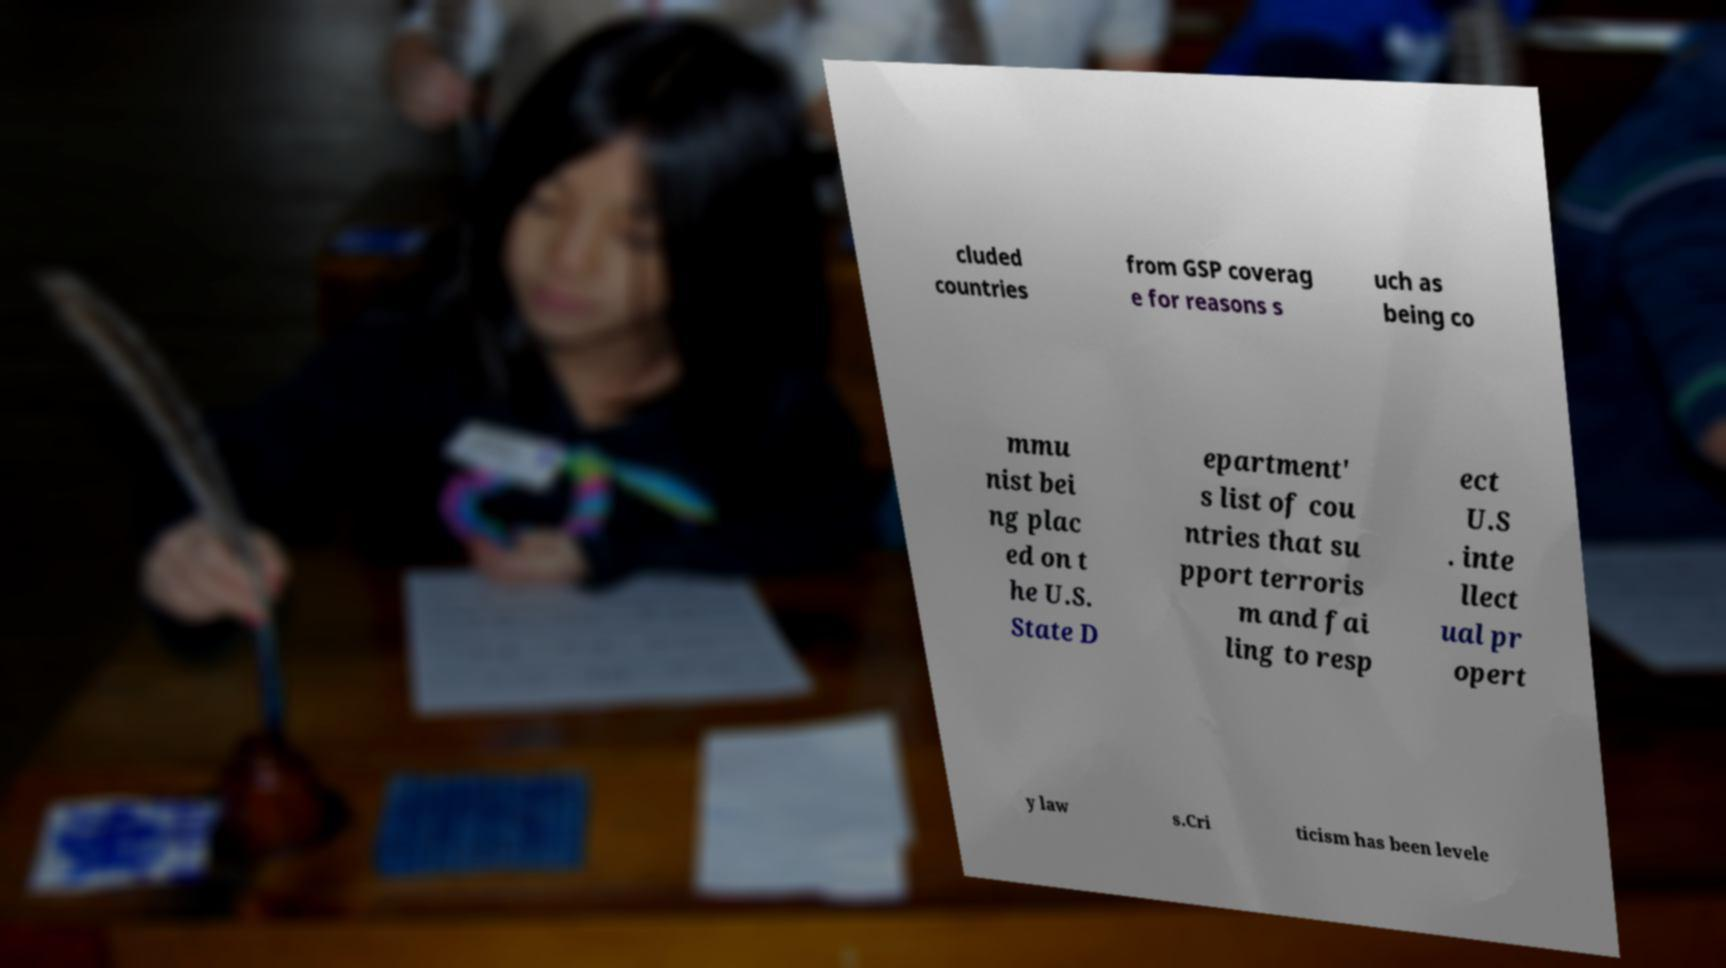For documentation purposes, I need the text within this image transcribed. Could you provide that? cluded countries from GSP coverag e for reasons s uch as being co mmu nist bei ng plac ed on t he U.S. State D epartment' s list of cou ntries that su pport terroris m and fai ling to resp ect U.S . inte llect ual pr opert y law s.Cri ticism has been levele 